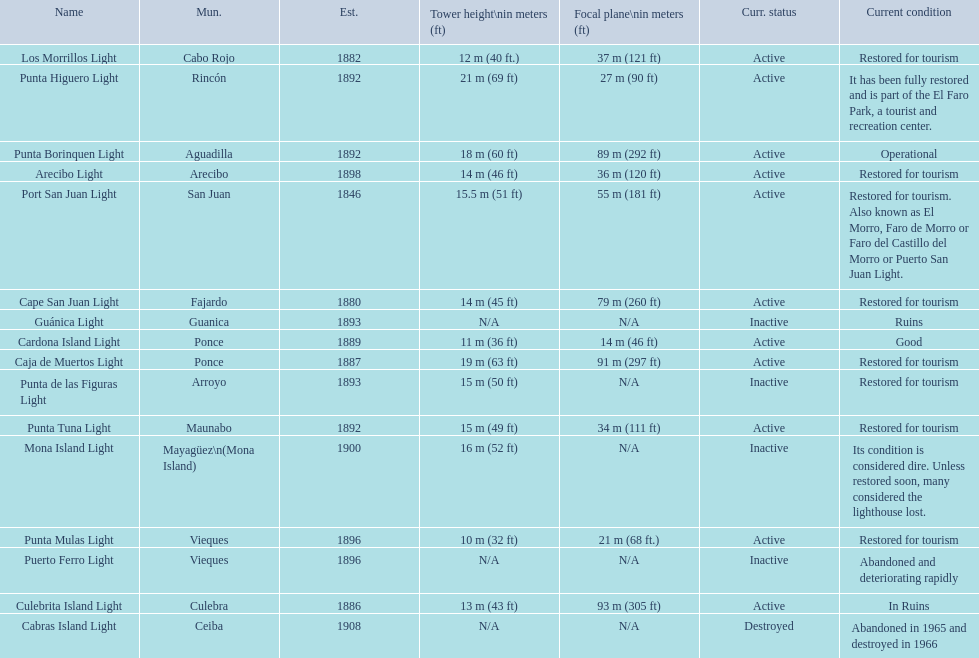What is the largest tower Punta Higuero Light. 